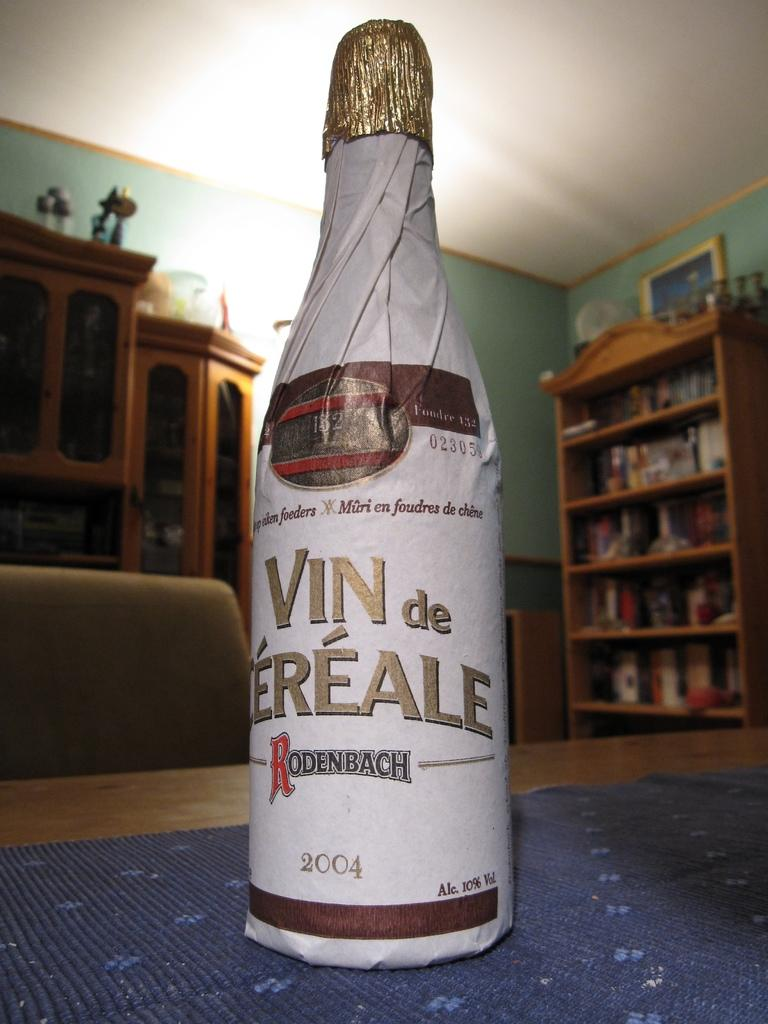What object is placed on the table in the image? There is a bottle on the table in the image. What can be seen in the background of the image? There are racks visible in the background of the image. What is hanging on the wall in the image? There is a frame on the wall in the image. What type of cheese is being divided in the image? There is no cheese present in the image, nor is there any division taking place. 